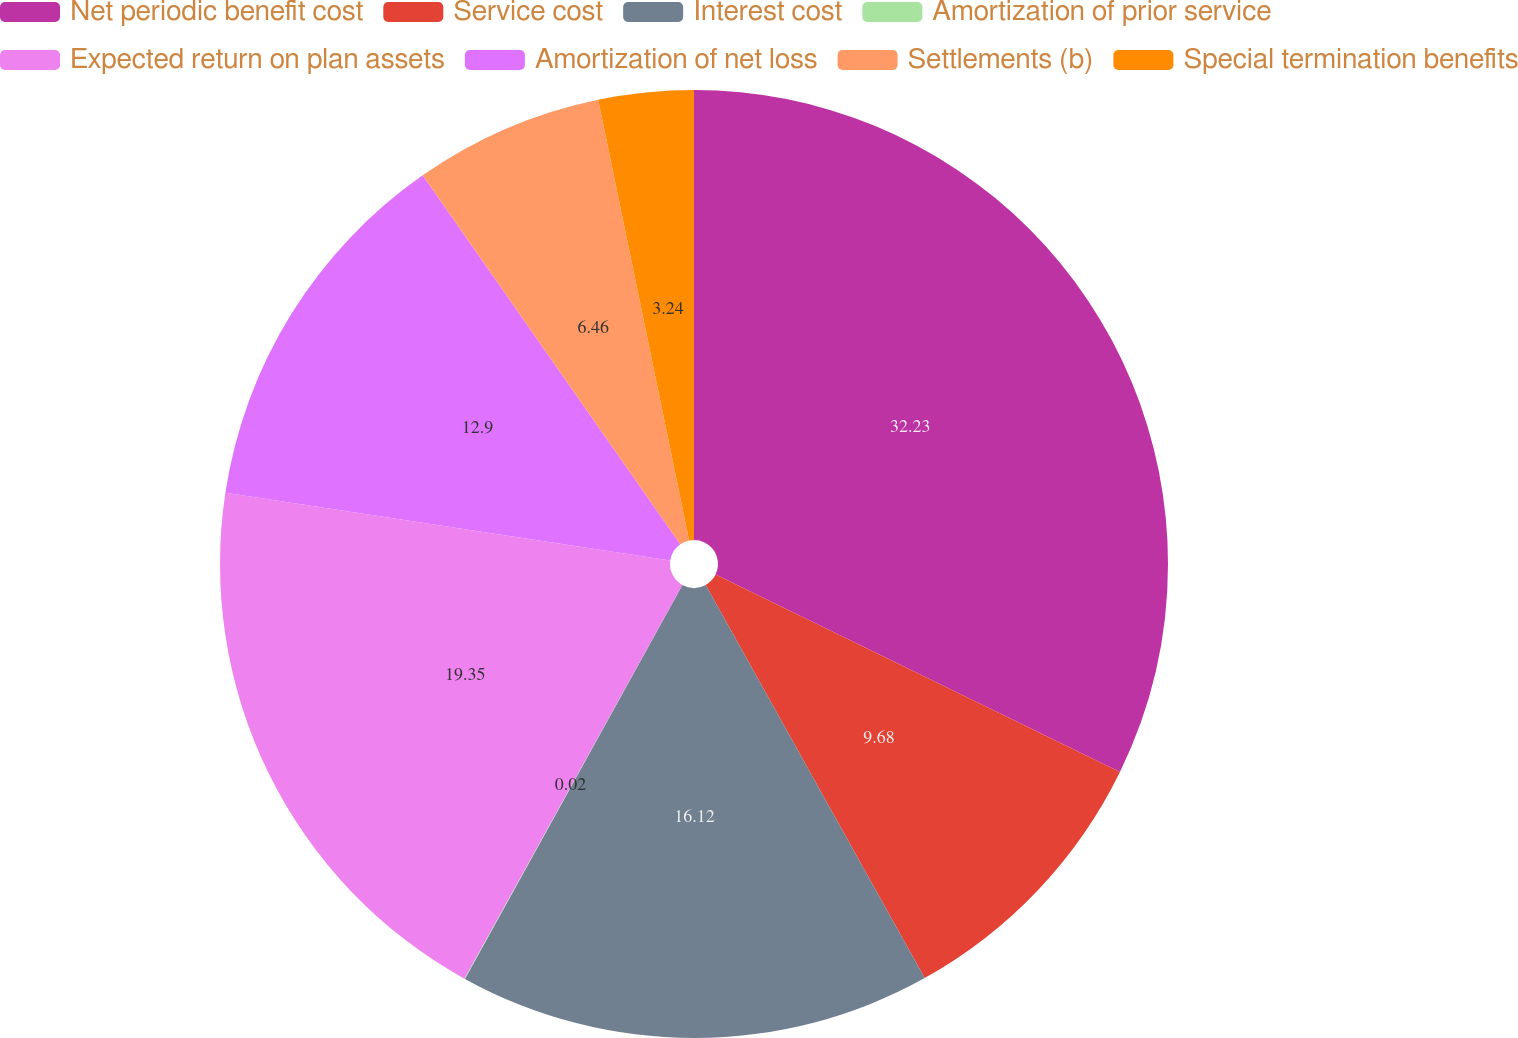Convert chart. <chart><loc_0><loc_0><loc_500><loc_500><pie_chart><fcel>Net periodic benefit cost<fcel>Service cost<fcel>Interest cost<fcel>Amortization of prior service<fcel>Expected return on plan assets<fcel>Amortization of net loss<fcel>Settlements (b)<fcel>Special termination benefits<nl><fcel>32.23%<fcel>9.68%<fcel>16.12%<fcel>0.02%<fcel>19.35%<fcel>12.9%<fcel>6.46%<fcel>3.24%<nl></chart> 